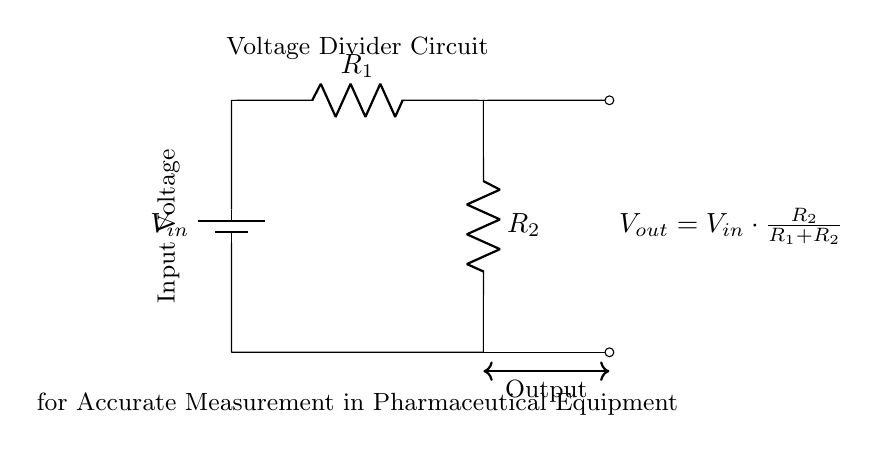What is the type of circuit shown? The circuit is a voltage divider, which divides the input voltage across two resistors.
Answer: voltage divider What are the values of R1 and R2 in the diagram? The diagram does not specify exact values for the resistors R1 and R2, only that they are part of the voltage divider configuration.
Answer: unspecified What is the output voltage formula derived from the circuit? The output voltage is given by the formula Vout = Vin * (R2 / (R1 + R2)), which describes how the output voltage is a fraction of the input voltage based on the resistor values.
Answer: Vout = Vin * (R2 / (R1 + R2)) What does the output voltage depend on? The output voltage depends on the input voltage and the ratio of the resistors R1 and R2, which determine how voltage is divided.
Answer: input voltage and resistor ratio If R1 equals 2 ohms and R2 equals 3 ohms, what is the output voltage when Vin is 10 volts? Using the formula, Vout = 10 * (3 / (2 + 3)) = 10 * (3 / 5) = 6 volts. So, the output voltage when R1 is 2 ohms, R2 is 3 ohms, and Vin is 10 volts is calculated as follows: Vout = 10 * (3 / (2 + 3)) = 6 volts.
Answer: 6 volts Why is this circuit suitable for pharmaceutical equipment? This circuit provides accurate voltage measurements that are critical for controlling and monitoring functions in pharmaceutical equipment, ensuring precise dosing and quality control.
Answer: accurate voltage measurements What is the significance of the drawn arrows in the circuit? The arrows indicate the direction of current flow, guiding the user's understanding of how the circuit operates and how voltage is distributed across components.
Answer: direction of current flow 